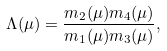Convert formula to latex. <formula><loc_0><loc_0><loc_500><loc_500>\Lambda ( \mu ) = \frac { m _ { 2 } ( \mu ) m _ { 4 } ( \mu ) } { m _ { 1 } ( \mu ) m _ { 3 } ( \mu ) } ,</formula> 